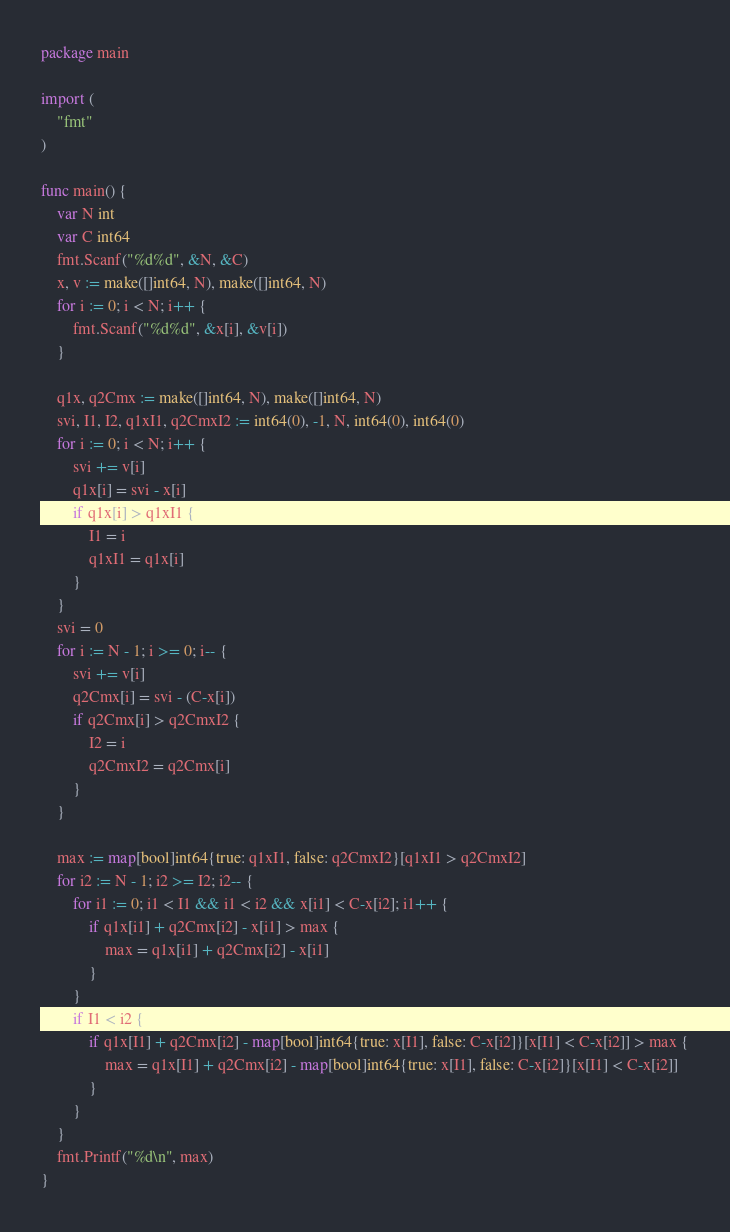Convert code to text. <code><loc_0><loc_0><loc_500><loc_500><_Go_>package main

import (
	"fmt"
)

func main() {
	var N int
	var C int64
	fmt.Scanf("%d%d", &N, &C)
	x, v := make([]int64, N), make([]int64, N)
	for i := 0; i < N; i++ {
		fmt.Scanf("%d%d", &x[i], &v[i])
	}

	q1x, q2Cmx := make([]int64, N), make([]int64, N)
	svi, I1, I2, q1xI1, q2CmxI2 := int64(0), -1, N, int64(0), int64(0)
	for i := 0; i < N; i++ {
		svi += v[i]
		q1x[i] = svi - x[i]
		if q1x[i] > q1xI1 {
			I1 = i
			q1xI1 = q1x[i]
		}
	}
	svi = 0
	for i := N - 1; i >= 0; i-- {
		svi += v[i]
		q2Cmx[i] = svi - (C-x[i])
		if q2Cmx[i] > q2CmxI2 {
			I2 = i
			q2CmxI2 = q2Cmx[i]
		}
	}

	max := map[bool]int64{true: q1xI1, false: q2CmxI2}[q1xI1 > q2CmxI2]
	for i2 := N - 1; i2 >= I2; i2-- {
		for i1 := 0; i1 < I1 && i1 < i2 && x[i1] < C-x[i2]; i1++ {
			if q1x[i1] + q2Cmx[i2] - x[i1] > max {
				max = q1x[i1] + q2Cmx[i2] - x[i1]
			}
		}
		if I1 < i2 {
			if q1x[I1] + q2Cmx[i2] - map[bool]int64{true: x[I1], false: C-x[i2]}[x[I1] < C-x[i2]] > max {
				max = q1x[I1] + q2Cmx[i2] - map[bool]int64{true: x[I1], false: C-x[i2]}[x[I1] < C-x[i2]]
			}
		}
	}
	fmt.Printf("%d\n", max)
}

</code> 